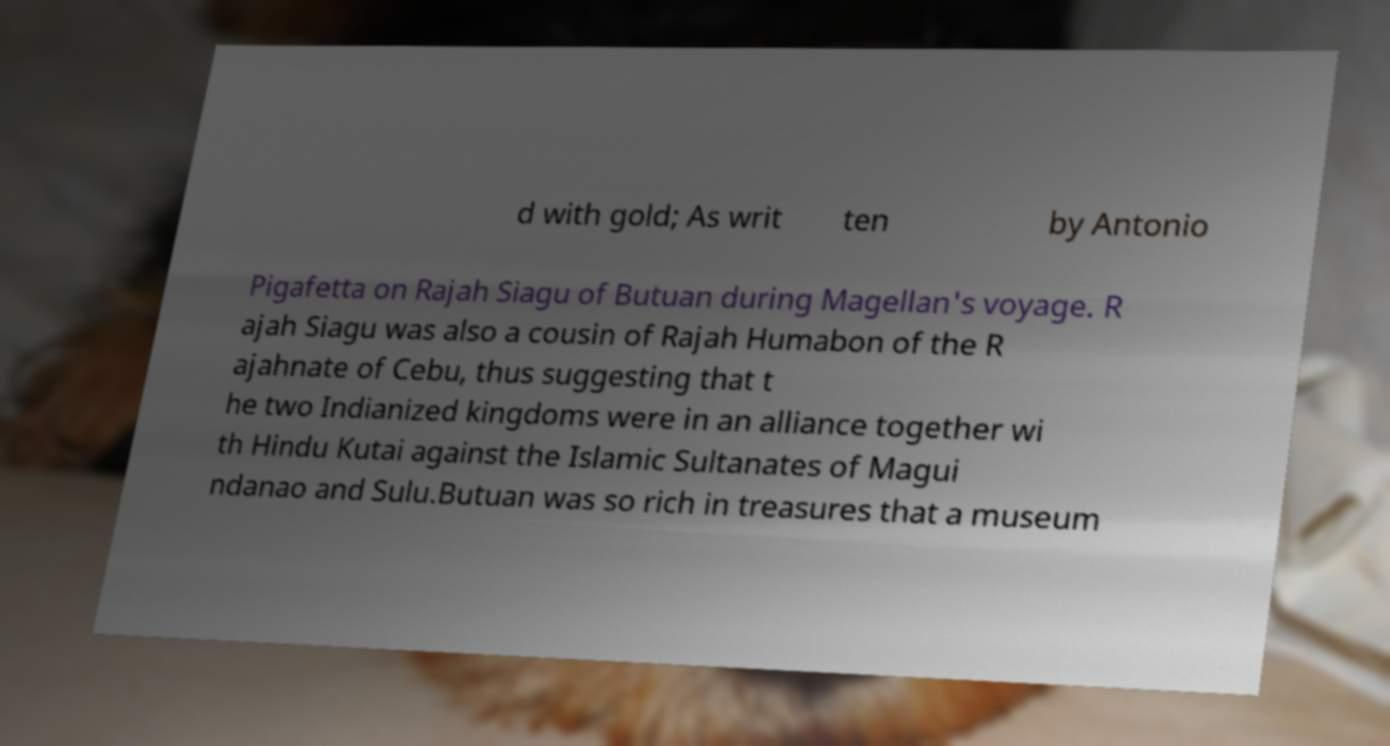Can you read and provide the text displayed in the image?This photo seems to have some interesting text. Can you extract and type it out for me? d with gold; As writ ten by Antonio Pigafetta on Rajah Siagu of Butuan during Magellan's voyage. R ajah Siagu was also a cousin of Rajah Humabon of the R ajahnate of Cebu, thus suggesting that t he two Indianized kingdoms were in an alliance together wi th Hindu Kutai against the Islamic Sultanates of Magui ndanao and Sulu.Butuan was so rich in treasures that a museum 